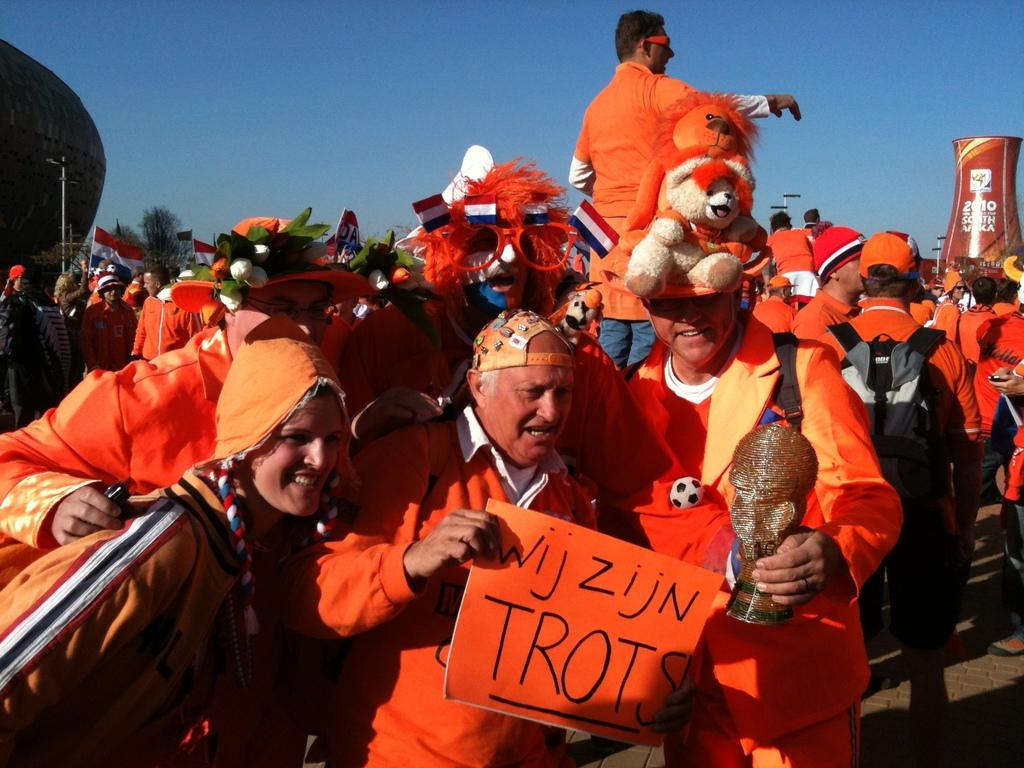How many people are in the image? There is a group of people in the image. What are the people in the image doing? The people are standing on the road. What can be seen in the background of the image? There is a sky visible in the background of the image. What type of nut can be seen rolling down the road in the image? There is no nut present in the image, and therefore no such activity can be observed. 